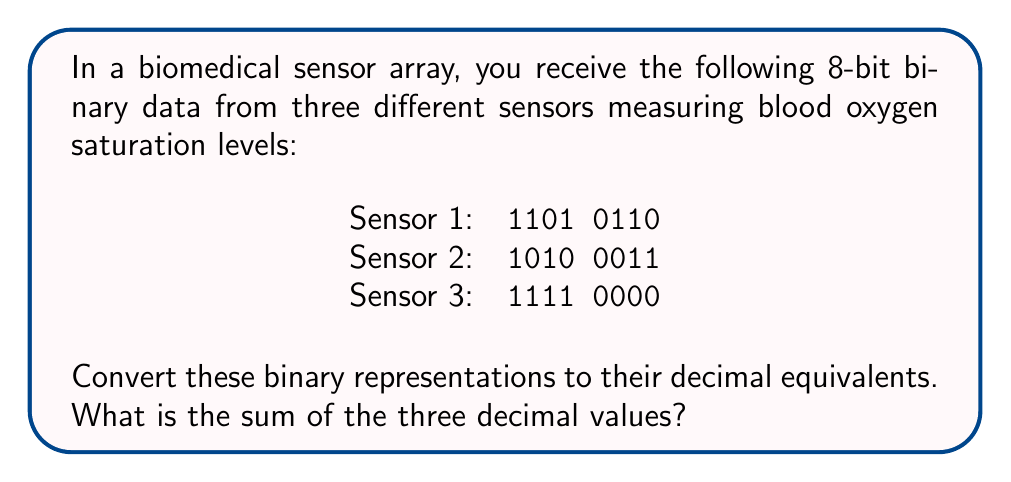Help me with this question. To convert binary to decimal, we use the following method:

1. For Sensor 1 (11010110):
   $$(1 \times 2^7) + (1 \times 2^6) + (0 \times 2^5) + (1 \times 2^4) + (0 \times 2^3) + (1 \times 2^2) + (1 \times 2^1) + (0 \times 2^0)$$
   $$= 128 + 64 + 0 + 16 + 0 + 4 + 2 + 0 = 214$$

2. For Sensor 2 (10100011):
   $$(1 \times 2^7) + (0 \times 2^6) + (1 \times 2^5) + (0 \times 2^4) + (0 \times 2^3) + (0 \times 2^2) + (1 \times 2^1) + (1 \times 2^0)$$
   $$= 128 + 0 + 32 + 0 + 0 + 0 + 2 + 1 = 163$$

3. For Sensor 3 (11110000):
   $$(1 \times 2^7) + (1 \times 2^6) + (1 \times 2^5) + (1 \times 2^4) + (0 \times 2^3) + (0 \times 2^2) + (0 \times 2^1) + (0 \times 2^0)$$
   $$= 128 + 64 + 32 + 16 + 0 + 0 + 0 + 0 = 240$$

4. Sum of the three decimal values:
   $$214 + 163 + 240 = 617$$
Answer: 617 